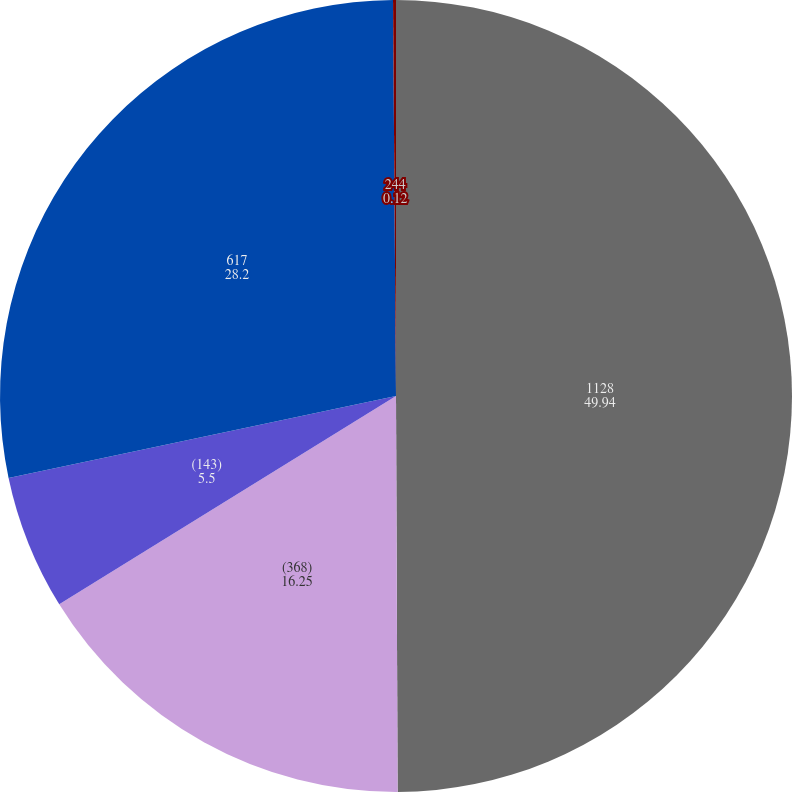Convert chart to OTSL. <chart><loc_0><loc_0><loc_500><loc_500><pie_chart><fcel>1128<fcel>(368)<fcel>(143)<fcel>617<fcel>244<nl><fcel>49.94%<fcel>16.25%<fcel>5.5%<fcel>28.2%<fcel>0.12%<nl></chart> 